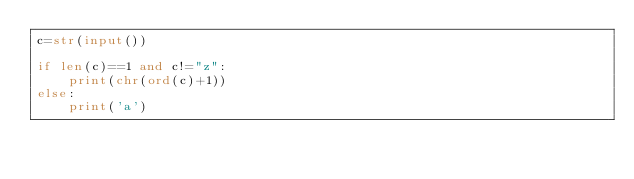<code> <loc_0><loc_0><loc_500><loc_500><_Python_>c=str(input())

if len(c)==1 and c!="z":
	print(chr(ord(c)+1))
else:
	print('a')
</code> 